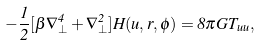<formula> <loc_0><loc_0><loc_500><loc_500>- \frac { 1 } { 2 } [ \beta \nabla _ { \perp } ^ { 4 } + \nabla _ { \perp } ^ { 2 } ] H ( u , r , \phi ) = 8 \pi G T _ { u u } ,</formula> 